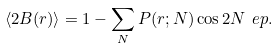<formula> <loc_0><loc_0><loc_500><loc_500>\left \langle 2 B ( r ) \right \rangle = 1 - \sum _ { N } P ( r ; N ) \cos { 2 N \ e p } .</formula> 